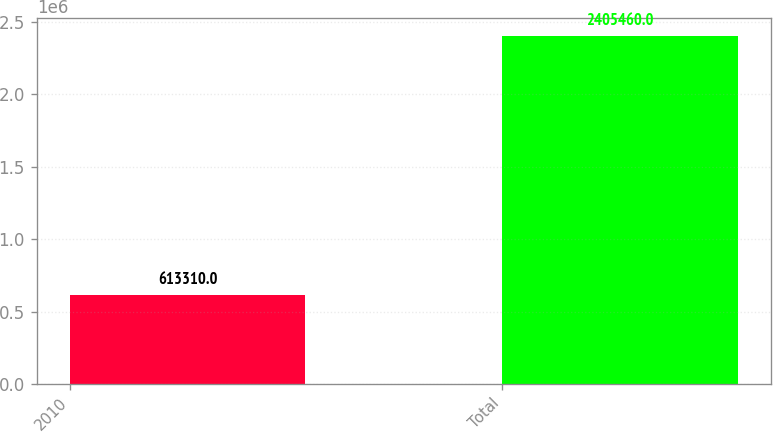Convert chart. <chart><loc_0><loc_0><loc_500><loc_500><bar_chart><fcel>2010<fcel>Total<nl><fcel>613310<fcel>2.40546e+06<nl></chart> 